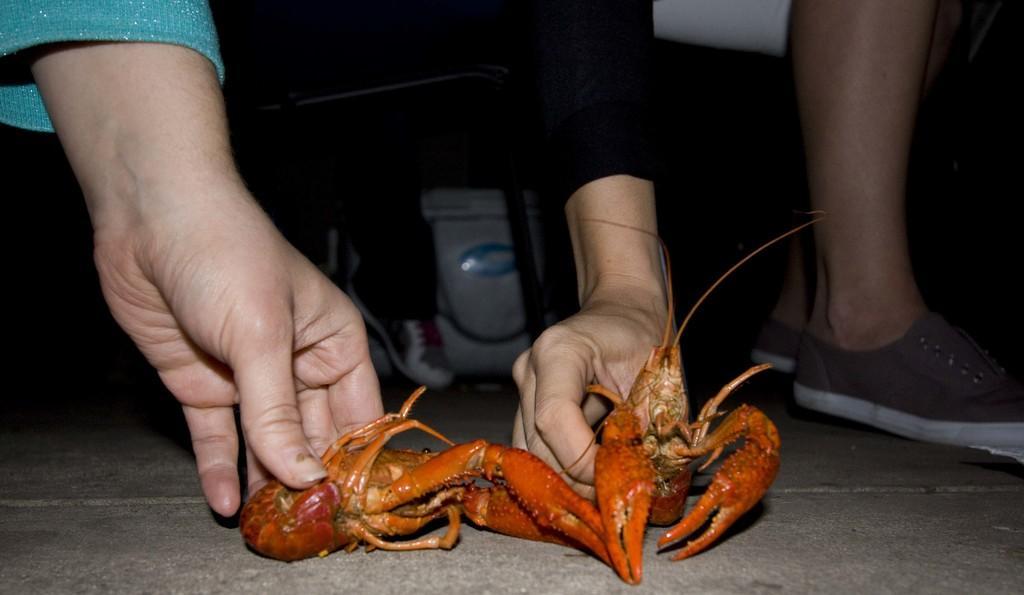Describe this image in one or two sentences. In this image we can see two people holding an animal which looks like a crab and there is a white color object in the background. 